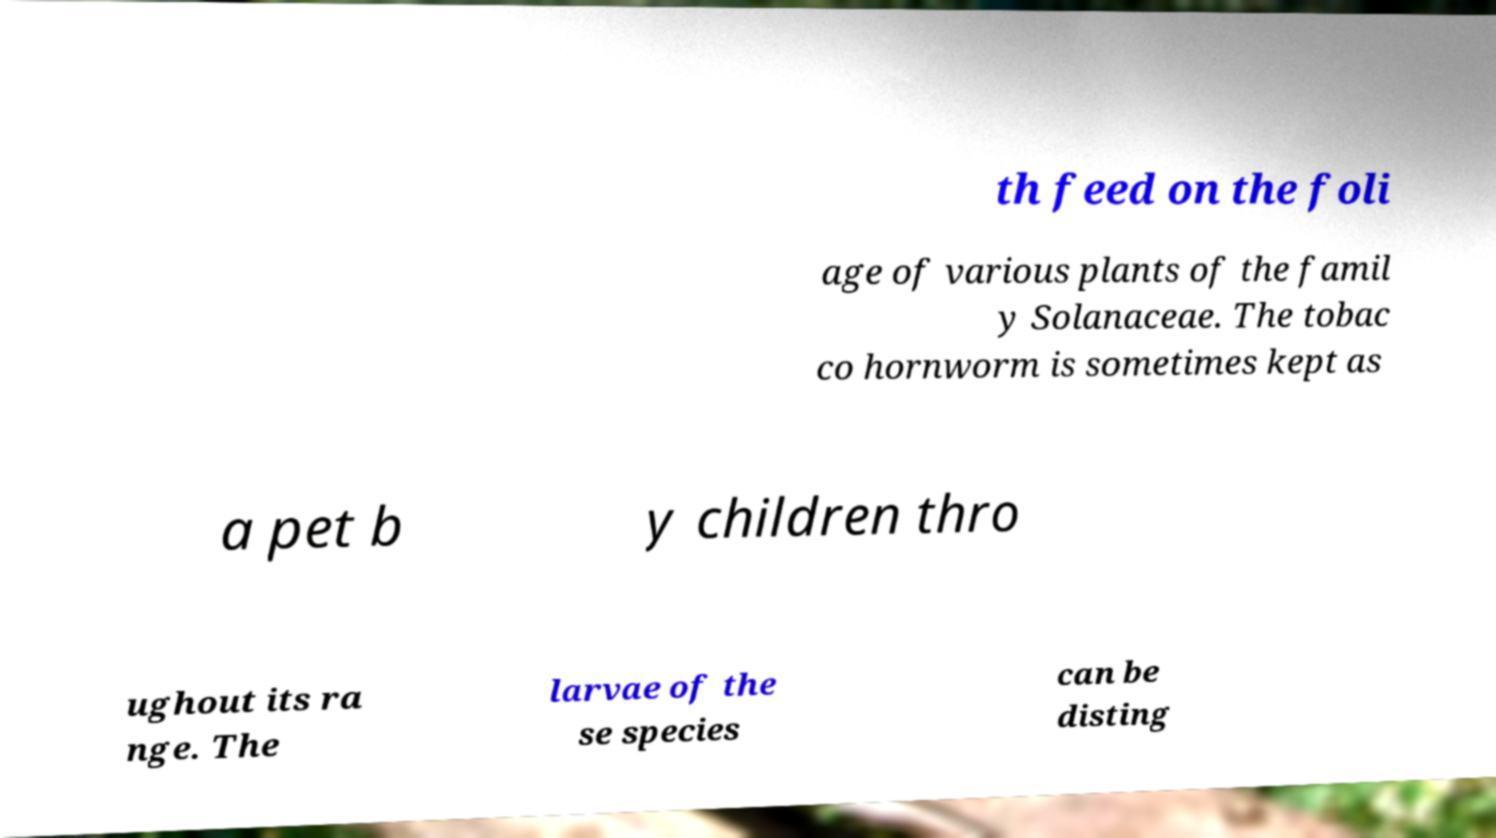Could you assist in decoding the text presented in this image and type it out clearly? th feed on the foli age of various plants of the famil y Solanaceae. The tobac co hornworm is sometimes kept as a pet b y children thro ughout its ra nge. The larvae of the se species can be disting 